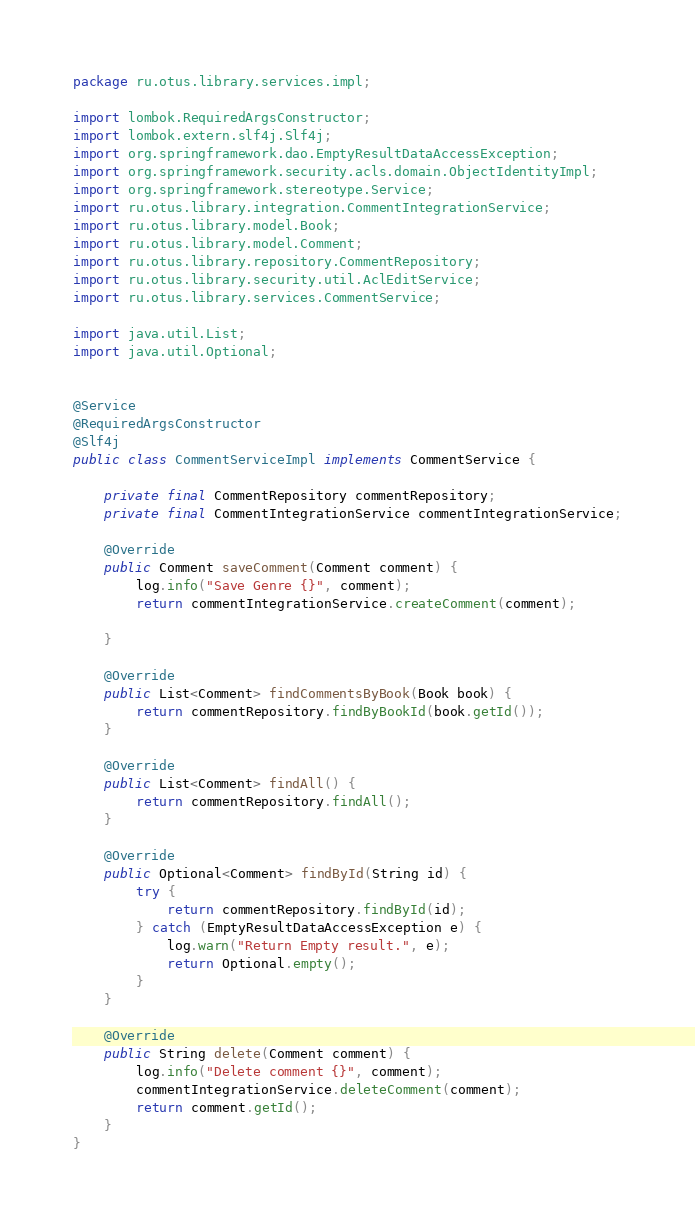<code> <loc_0><loc_0><loc_500><loc_500><_Java_>package ru.otus.library.services.impl;

import lombok.RequiredArgsConstructor;
import lombok.extern.slf4j.Slf4j;
import org.springframework.dao.EmptyResultDataAccessException;
import org.springframework.security.acls.domain.ObjectIdentityImpl;
import org.springframework.stereotype.Service;
import ru.otus.library.integration.CommentIntegrationService;
import ru.otus.library.model.Book;
import ru.otus.library.model.Comment;
import ru.otus.library.repository.CommentRepository;
import ru.otus.library.security.util.AclEditService;
import ru.otus.library.services.CommentService;

import java.util.List;
import java.util.Optional;


@Service
@RequiredArgsConstructor
@Slf4j
public class CommentServiceImpl implements CommentService {

    private final CommentRepository commentRepository;
    private final CommentIntegrationService commentIntegrationService;

    @Override
    public Comment saveComment(Comment comment) {
        log.info("Save Genre {}", comment);
        return commentIntegrationService.createComment(comment);

    }

    @Override
    public List<Comment> findCommentsByBook(Book book) {
        return commentRepository.findByBookId(book.getId());
    }

    @Override
    public List<Comment> findAll() {
        return commentRepository.findAll();
    }

    @Override
    public Optional<Comment> findById(String id) {
        try {
            return commentRepository.findById(id);
        } catch (EmptyResultDataAccessException e) {
            log.warn("Return Empty result.", e);
            return Optional.empty();
        }
    }

    @Override
    public String delete(Comment comment) {
        log.info("Delete comment {}", comment);
        commentIntegrationService.deleteComment(comment);
        return comment.getId();
    }
}
</code> 